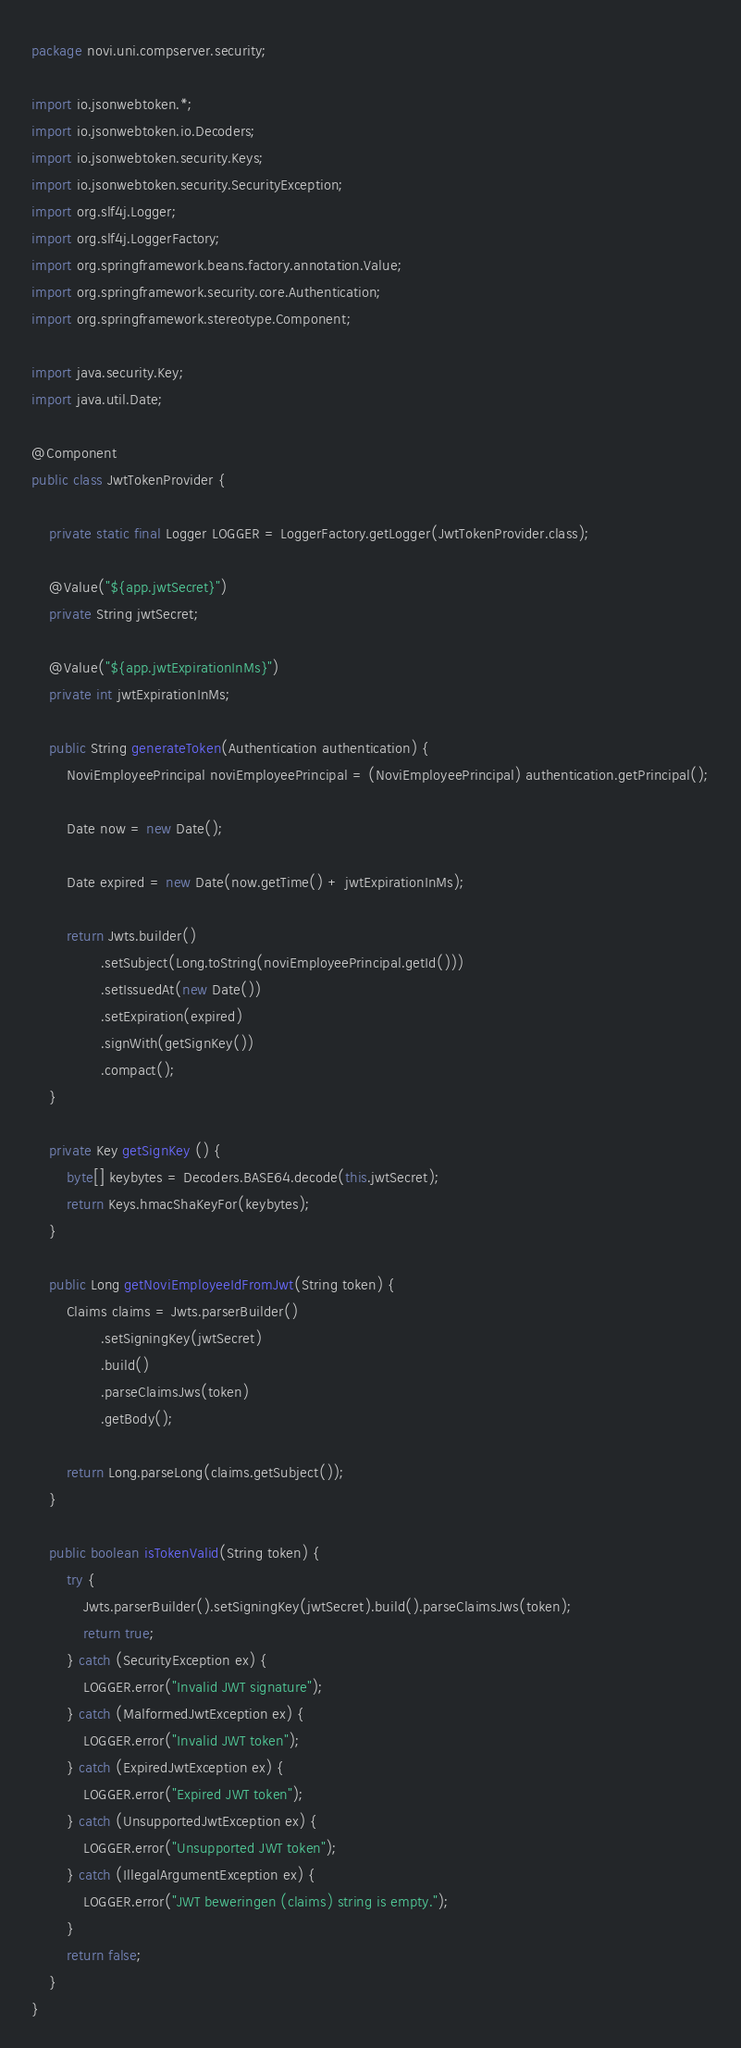Convert code to text. <code><loc_0><loc_0><loc_500><loc_500><_Java_>package novi.uni.compserver.security;

import io.jsonwebtoken.*;
import io.jsonwebtoken.io.Decoders;
import io.jsonwebtoken.security.Keys;
import io.jsonwebtoken.security.SecurityException;
import org.slf4j.Logger;
import org.slf4j.LoggerFactory;
import org.springframework.beans.factory.annotation.Value;
import org.springframework.security.core.Authentication;
import org.springframework.stereotype.Component;

import java.security.Key;
import java.util.Date;

@Component
public class JwtTokenProvider {

    private static final Logger LOGGER = LoggerFactory.getLogger(JwtTokenProvider.class);

    @Value("${app.jwtSecret}")
    private String jwtSecret;

    @Value("${app.jwtExpirationInMs}")
    private int jwtExpirationInMs;

    public String generateToken(Authentication authentication) {
        NoviEmployeePrincipal noviEmployeePrincipal = (NoviEmployeePrincipal) authentication.getPrincipal();

        Date now = new Date();

        Date expired = new Date(now.getTime() + jwtExpirationInMs);

        return Jwts.builder()
                .setSubject(Long.toString(noviEmployeePrincipal.getId()))
                .setIssuedAt(new Date())
                .setExpiration(expired)
                .signWith(getSignKey())
                .compact();
    }

    private Key getSignKey () {
        byte[] keybytes = Decoders.BASE64.decode(this.jwtSecret);
        return Keys.hmacShaKeyFor(keybytes);
    }

    public Long getNoviEmployeeIdFromJwt(String token) {
        Claims claims = Jwts.parserBuilder()
                .setSigningKey(jwtSecret)
                .build()
                .parseClaimsJws(token)
                .getBody();

        return Long.parseLong(claims.getSubject());
    }

    public boolean isTokenValid(String token) {
        try {
            Jwts.parserBuilder().setSigningKey(jwtSecret).build().parseClaimsJws(token);
            return true;
        } catch (SecurityException ex) {
            LOGGER.error("Invalid JWT signature");
        } catch (MalformedJwtException ex) {
            LOGGER.error("Invalid JWT token");
        } catch (ExpiredJwtException ex) {
            LOGGER.error("Expired JWT token");
        } catch (UnsupportedJwtException ex) {
            LOGGER.error("Unsupported JWT token");
        } catch (IllegalArgumentException ex) {
            LOGGER.error("JWT beweringen (claims) string is empty.");
        }
        return false;
    }
}
</code> 